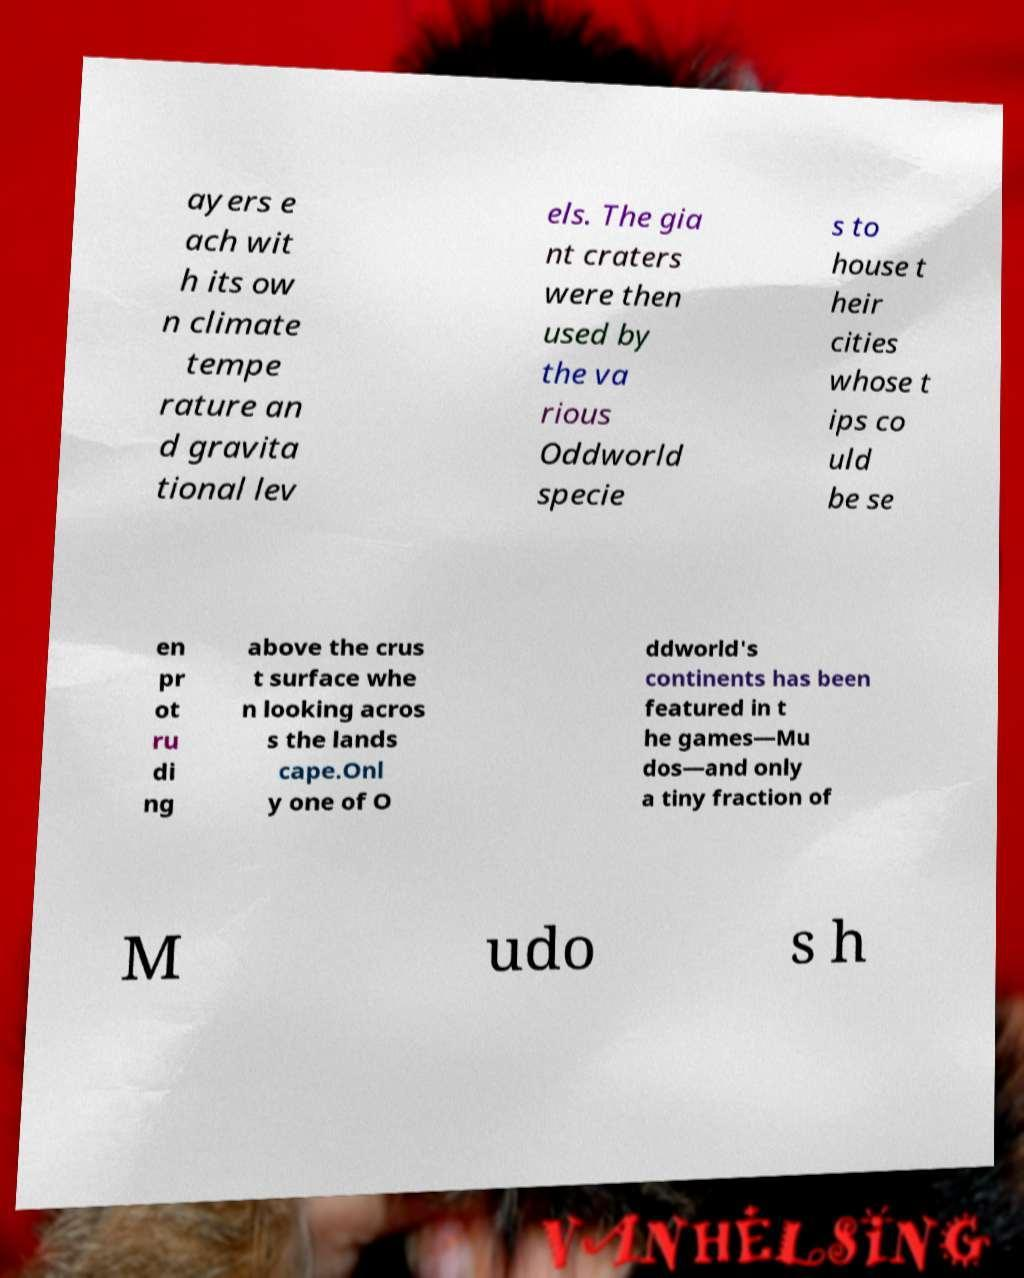Could you extract and type out the text from this image? ayers e ach wit h its ow n climate tempe rature an d gravita tional lev els. The gia nt craters were then used by the va rious Oddworld specie s to house t heir cities whose t ips co uld be se en pr ot ru di ng above the crus t surface whe n looking acros s the lands cape.Onl y one of O ddworld's continents has been featured in t he games—Mu dos—and only a tiny fraction of M udo s h 